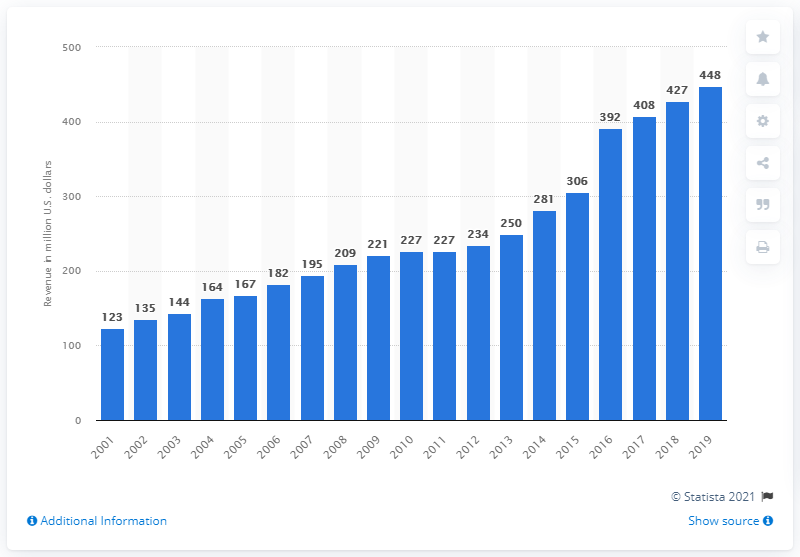Point out several critical features in this image. In 2019, the revenue of the Minnesota Vikings was 448 million dollars. 